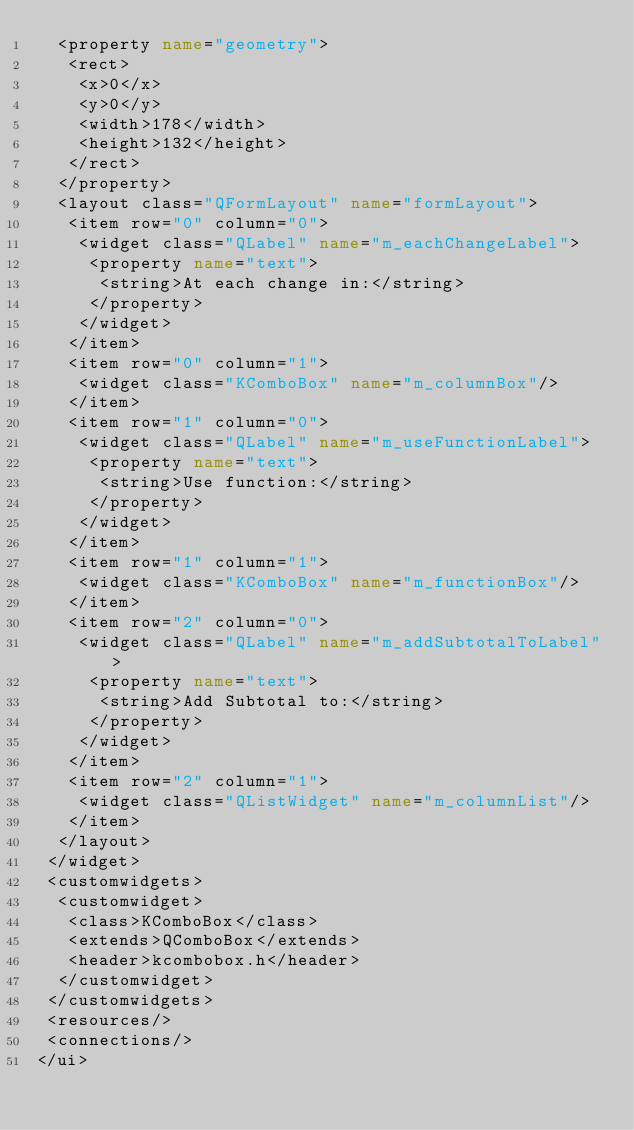<code> <loc_0><loc_0><loc_500><loc_500><_XML_>  <property name="geometry">
   <rect>
    <x>0</x>
    <y>0</y>
    <width>178</width>
    <height>132</height>
   </rect>
  </property>
  <layout class="QFormLayout" name="formLayout">
   <item row="0" column="0">
    <widget class="QLabel" name="m_eachChangeLabel">
     <property name="text">
      <string>At each change in:</string>
     </property>
    </widget>
   </item>
   <item row="0" column="1">
    <widget class="KComboBox" name="m_columnBox"/>
   </item>
   <item row="1" column="0">
    <widget class="QLabel" name="m_useFunctionLabel">
     <property name="text">
      <string>Use function:</string>
     </property>
    </widget>
   </item>
   <item row="1" column="1">
    <widget class="KComboBox" name="m_functionBox"/>
   </item>
   <item row="2" column="0">
    <widget class="QLabel" name="m_addSubtotalToLabel">
     <property name="text">
      <string>Add Subtotal to:</string>
     </property>
    </widget>
   </item>
   <item row="2" column="1">
    <widget class="QListWidget" name="m_columnList"/>
   </item>
  </layout>
 </widget>
 <customwidgets>
  <customwidget>
   <class>KComboBox</class>
   <extends>QComboBox</extends>
   <header>kcombobox.h</header>
  </customwidget>
 </customwidgets>
 <resources/>
 <connections/>
</ui>
</code> 